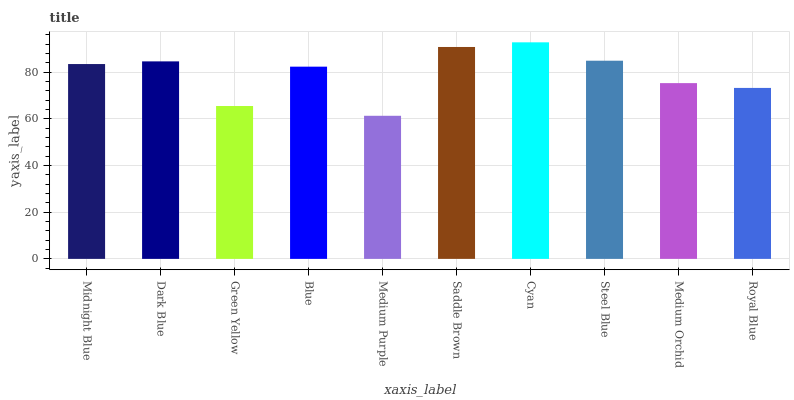Is Medium Purple the minimum?
Answer yes or no. Yes. Is Cyan the maximum?
Answer yes or no. Yes. Is Dark Blue the minimum?
Answer yes or no. No. Is Dark Blue the maximum?
Answer yes or no. No. Is Dark Blue greater than Midnight Blue?
Answer yes or no. Yes. Is Midnight Blue less than Dark Blue?
Answer yes or no. Yes. Is Midnight Blue greater than Dark Blue?
Answer yes or no. No. Is Dark Blue less than Midnight Blue?
Answer yes or no. No. Is Midnight Blue the high median?
Answer yes or no. Yes. Is Blue the low median?
Answer yes or no. Yes. Is Blue the high median?
Answer yes or no. No. Is Steel Blue the low median?
Answer yes or no. No. 